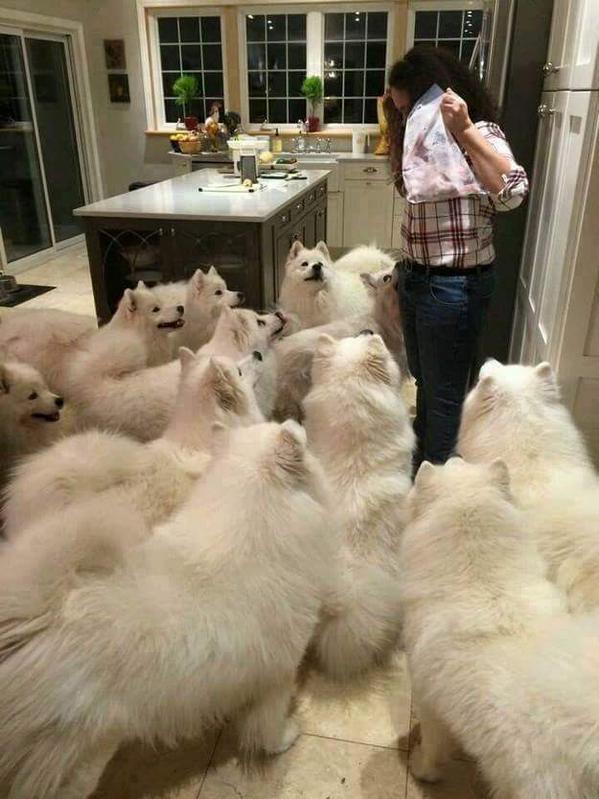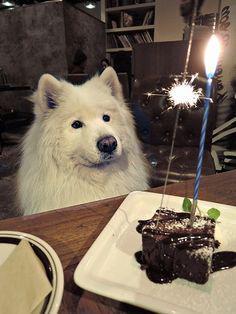The first image is the image on the left, the second image is the image on the right. Analyze the images presented: Is the assertion "One image has a dog wearing more than just a collar or leash." valid? Answer yes or no. No. The first image is the image on the left, the second image is the image on the right. For the images shown, is this caption "In at least one image you can see at least one human wearing jeans feeding no less than 6 white dogs." true? Answer yes or no. Yes. 